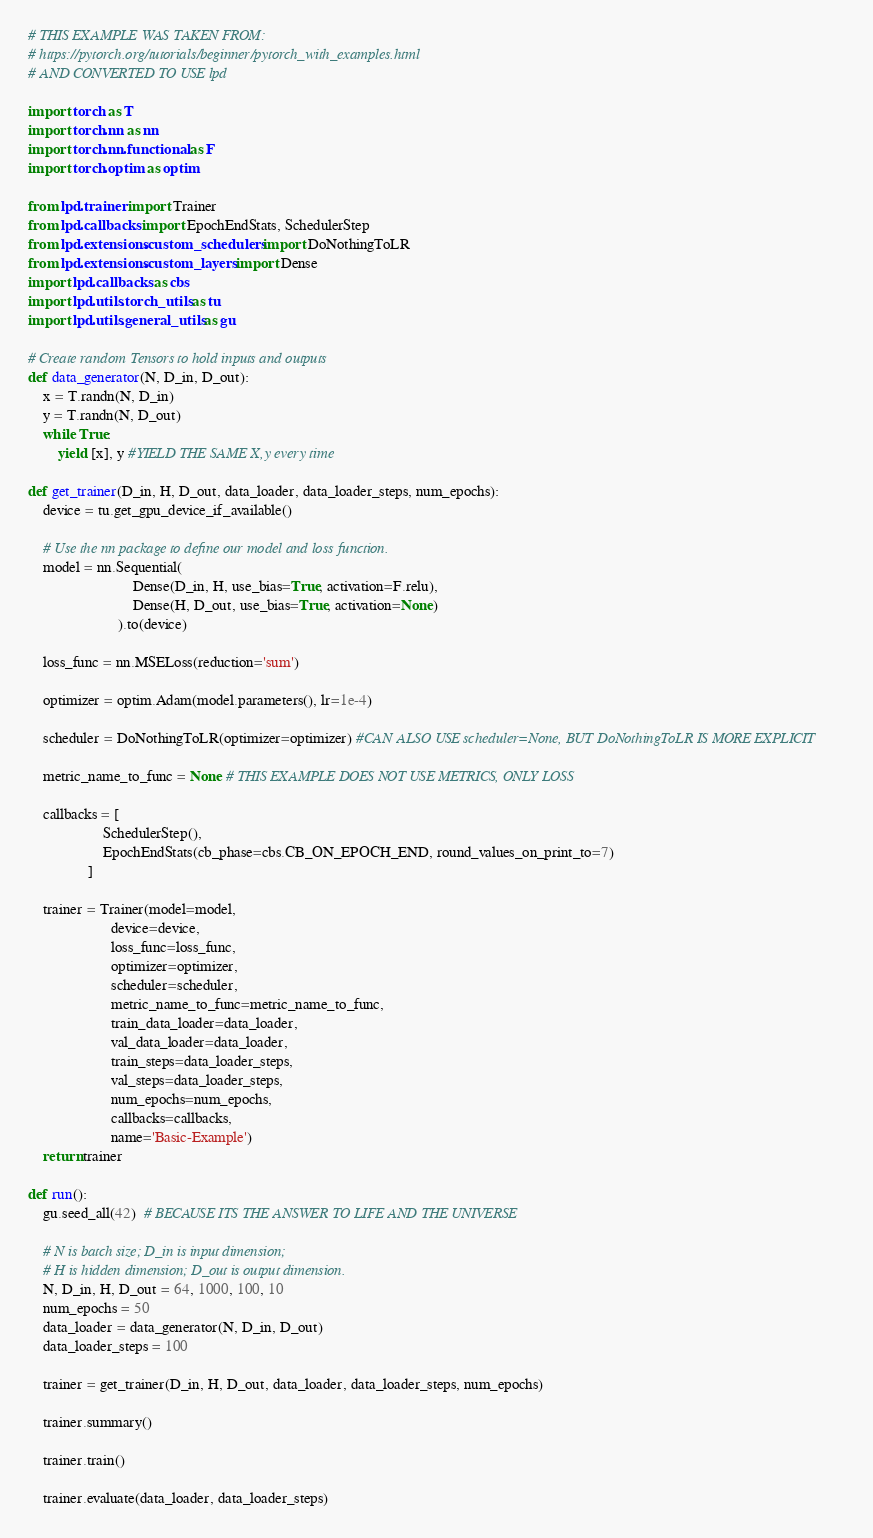<code> <loc_0><loc_0><loc_500><loc_500><_Python_># THIS EXAMPLE WAS TAKEN FROM:
# https://pytorch.org/tutorials/beginner/pytorch_with_examples.html
# AND CONVERTED TO USE lpd

import torch as T
import torch.nn as nn
import torch.nn.functional as F
import torch.optim as optim

from lpd.trainer import Trainer
from lpd.callbacks import EpochEndStats, SchedulerStep
from lpd.extensions.custom_schedulers import DoNothingToLR
from lpd.extensions.custom_layers import Dense
import lpd.callbacks as cbs 
import lpd.utils.torch_utils as tu
import lpd.utils.general_utils as gu

# Create random Tensors to hold inputs and outputs
def data_generator(N, D_in, D_out):
    x = T.randn(N, D_in)
    y = T.randn(N, D_out)
    while True:
        yield [x], y #YIELD THE SAME X,y every time

def get_trainer(D_in, H, D_out, data_loader, data_loader_steps, num_epochs):
    device = tu.get_gpu_device_if_available()

    # Use the nn package to define our model and loss function.
    model = nn.Sequential(
                            Dense(D_in, H, use_bias=True, activation=F.relu),
                            Dense(H, D_out, use_bias=True, activation=None)
                        ).to(device)

    loss_func = nn.MSELoss(reduction='sum')
   
    optimizer = optim.Adam(model.parameters(), lr=1e-4)

    scheduler = DoNothingToLR(optimizer=optimizer) #CAN ALSO USE scheduler=None, BUT DoNothingToLR IS MORE EXPLICIT
    
    metric_name_to_func = None # THIS EXAMPLE DOES NOT USE METRICS, ONLY LOSS

    callbacks = [   
                    SchedulerStep(),
                    EpochEndStats(cb_phase=cbs.CB_ON_EPOCH_END, round_values_on_print_to=7)
                ]

    trainer = Trainer(model=model, 
                      device=device, 
                      loss_func=loss_func, 
                      optimizer=optimizer,
                      scheduler=scheduler,
                      metric_name_to_func=metric_name_to_func, 
                      train_data_loader=data_loader, 
                      val_data_loader=data_loader,
                      train_steps=data_loader_steps,
                      val_steps=data_loader_steps,
                      num_epochs=num_epochs,
                      callbacks=callbacks,
                      name='Basic-Example')
    return trainer

def run():
    gu.seed_all(42)  # BECAUSE ITS THE ANSWER TO LIFE AND THE UNIVERSE

    # N is batch size; D_in is input dimension;
    # H is hidden dimension; D_out is output dimension.
    N, D_in, H, D_out = 64, 1000, 100, 10
    num_epochs = 50
    data_loader = data_generator(N, D_in, D_out)
    data_loader_steps = 100

    trainer = get_trainer(D_in, H, D_out, data_loader, data_loader_steps, num_epochs)
    
    trainer.summary()

    trainer.train()

    trainer.evaluate(data_loader, data_loader_steps)</code> 